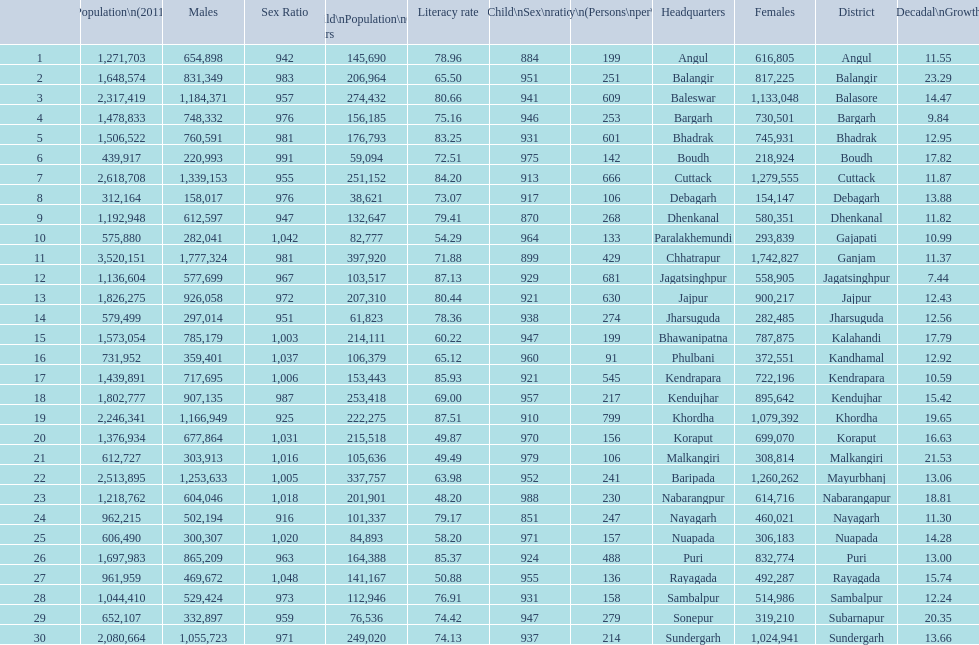I'm looking to parse the entire table for insights. Could you assist me with that? {'header': ['', 'Population\\n(2011)', 'Males', 'Sex Ratio', 'Child\\nPopulation\\n0–6 years', 'Literacy rate', 'Child\\nSex\\nratio', 'Density\\n(Persons\\nper\\nkm2)', 'Headquarters', 'Females', 'District', 'Percentage\\nDecadal\\nGrowth\\n2001-2011'], 'rows': [['1', '1,271,703', '654,898', '942', '145,690', '78.96', '884', '199', 'Angul', '616,805', 'Angul', '11.55'], ['2', '1,648,574', '831,349', '983', '206,964', '65.50', '951', '251', 'Balangir', '817,225', 'Balangir', '23.29'], ['3', '2,317,419', '1,184,371', '957', '274,432', '80.66', '941', '609', 'Baleswar', '1,133,048', 'Balasore', '14.47'], ['4', '1,478,833', '748,332', '976', '156,185', '75.16', '946', '253', 'Bargarh', '730,501', 'Bargarh', '9.84'], ['5', '1,506,522', '760,591', '981', '176,793', '83.25', '931', '601', 'Bhadrak', '745,931', 'Bhadrak', '12.95'], ['6', '439,917', '220,993', '991', '59,094', '72.51', '975', '142', 'Boudh', '218,924', 'Boudh', '17.82'], ['7', '2,618,708', '1,339,153', '955', '251,152', '84.20', '913', '666', 'Cuttack', '1,279,555', 'Cuttack', '11.87'], ['8', '312,164', '158,017', '976', '38,621', '73.07', '917', '106', 'Debagarh', '154,147', 'Debagarh', '13.88'], ['9', '1,192,948', '612,597', '947', '132,647', '79.41', '870', '268', 'Dhenkanal', '580,351', 'Dhenkanal', '11.82'], ['10', '575,880', '282,041', '1,042', '82,777', '54.29', '964', '133', 'Paralakhemundi', '293,839', 'Gajapati', '10.99'], ['11', '3,520,151', '1,777,324', '981', '397,920', '71.88', '899', '429', 'Chhatrapur', '1,742,827', 'Ganjam', '11.37'], ['12', '1,136,604', '577,699', '967', '103,517', '87.13', '929', '681', 'Jagatsinghpur', '558,905', 'Jagatsinghpur', '7.44'], ['13', '1,826,275', '926,058', '972', '207,310', '80.44', '921', '630', 'Jajpur', '900,217', 'Jajpur', '12.43'], ['14', '579,499', '297,014', '951', '61,823', '78.36', '938', '274', 'Jharsuguda', '282,485', 'Jharsuguda', '12.56'], ['15', '1,573,054', '785,179', '1,003', '214,111', '60.22', '947', '199', 'Bhawanipatna', '787,875', 'Kalahandi', '17.79'], ['16', '731,952', '359,401', '1,037', '106,379', '65.12', '960', '91', 'Phulbani', '372,551', 'Kandhamal', '12.92'], ['17', '1,439,891', '717,695', '1,006', '153,443', '85.93', '921', '545', 'Kendrapara', '722,196', 'Kendrapara', '10.59'], ['18', '1,802,777', '907,135', '987', '253,418', '69.00', '957', '217', 'Kendujhar', '895,642', 'Kendujhar', '15.42'], ['19', '2,246,341', '1,166,949', '925', '222,275', '87.51', '910', '799', 'Khordha', '1,079,392', 'Khordha', '19.65'], ['20', '1,376,934', '677,864', '1,031', '215,518', '49.87', '970', '156', 'Koraput', '699,070', 'Koraput', '16.63'], ['21', '612,727', '303,913', '1,016', '105,636', '49.49', '979', '106', 'Malkangiri', '308,814', 'Malkangiri', '21.53'], ['22', '2,513,895', '1,253,633', '1,005', '337,757', '63.98', '952', '241', 'Baripada', '1,260,262', 'Mayurbhanj', '13.06'], ['23', '1,218,762', '604,046', '1,018', '201,901', '48.20', '988', '230', 'Nabarangpur', '614,716', 'Nabarangapur', '18.81'], ['24', '962,215', '502,194', '916', '101,337', '79.17', '851', '247', 'Nayagarh', '460,021', 'Nayagarh', '11.30'], ['25', '606,490', '300,307', '1,020', '84,893', '58.20', '971', '157', 'Nuapada', '306,183', 'Nuapada', '14.28'], ['26', '1,697,983', '865,209', '963', '164,388', '85.37', '924', '488', 'Puri', '832,774', 'Puri', '13.00'], ['27', '961,959', '469,672', '1,048', '141,167', '50.88', '955', '136', 'Rayagada', '492,287', 'Rayagada', '15.74'], ['28', '1,044,410', '529,424', '973', '112,946', '76.91', '931', '158', 'Sambalpur', '514,986', 'Sambalpur', '12.24'], ['29', '652,107', '332,897', '959', '76,536', '74.42', '947', '279', 'Sonepur', '319,210', 'Subarnapur', '20.35'], ['30', '2,080,664', '1,055,723', '971', '249,020', '74.13', '937', '214', 'Sundergarh', '1,024,941', 'Sundergarh', '13.66']]} How many females live in cuttack? 1,279,555. 